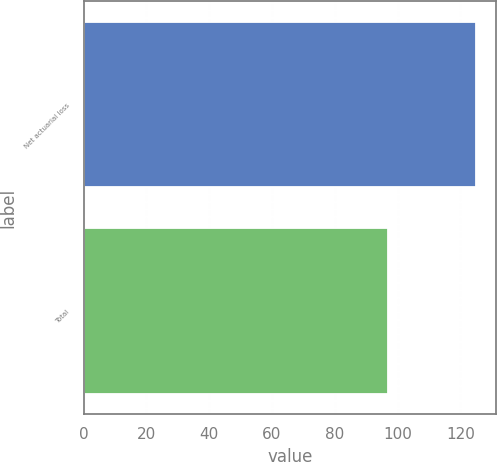Convert chart. <chart><loc_0><loc_0><loc_500><loc_500><bar_chart><fcel>Net actuarial loss<fcel>Total<nl><fcel>125<fcel>97<nl></chart> 